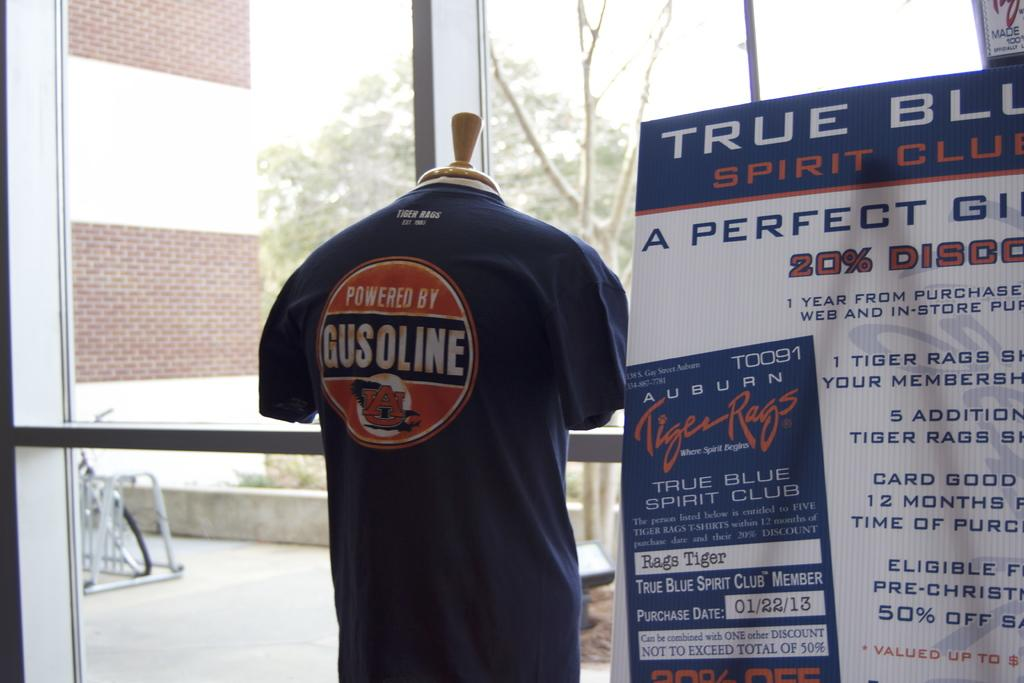<image>
Provide a brief description of the given image. A dark blue, Gusoline shirt is on display in the window, next to a True Blue Spirit Club poster. 